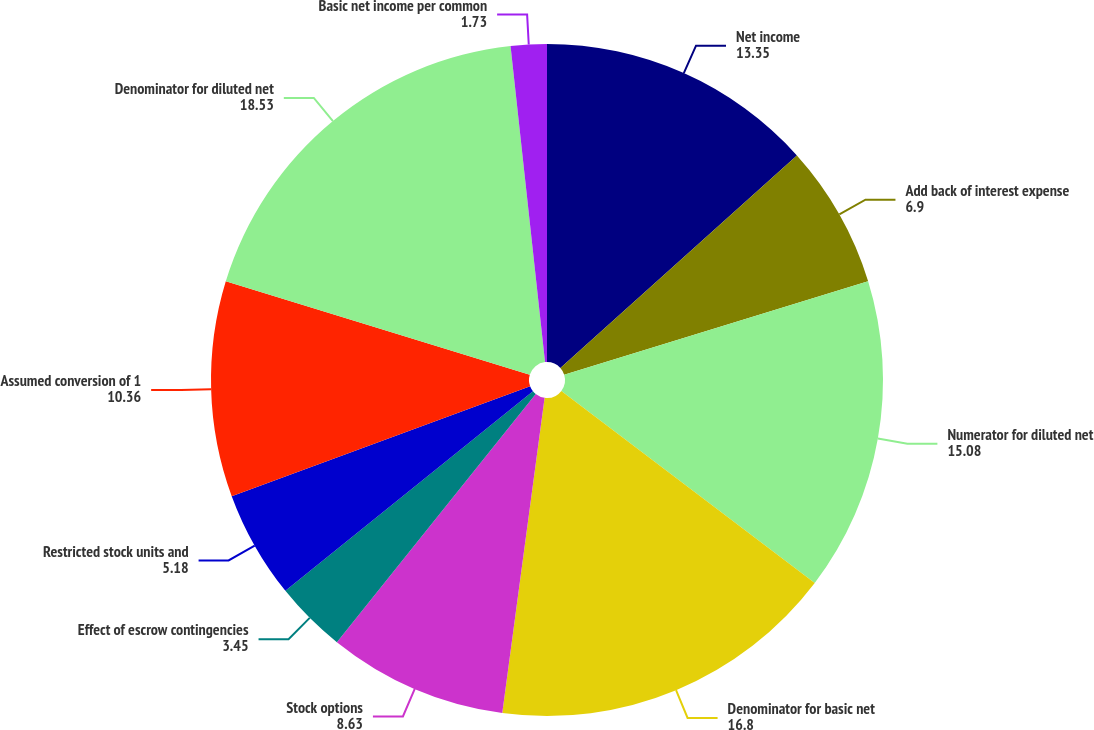Convert chart to OTSL. <chart><loc_0><loc_0><loc_500><loc_500><pie_chart><fcel>Net income<fcel>Add back of interest expense<fcel>Numerator for diluted net<fcel>Denominator for basic net<fcel>Stock options<fcel>Effect of escrow contingencies<fcel>Restricted stock units and<fcel>Assumed conversion of 1<fcel>Denominator for diluted net<fcel>Basic net income per common<nl><fcel>13.35%<fcel>6.9%<fcel>15.08%<fcel>16.8%<fcel>8.63%<fcel>3.45%<fcel>5.18%<fcel>10.36%<fcel>18.53%<fcel>1.73%<nl></chart> 